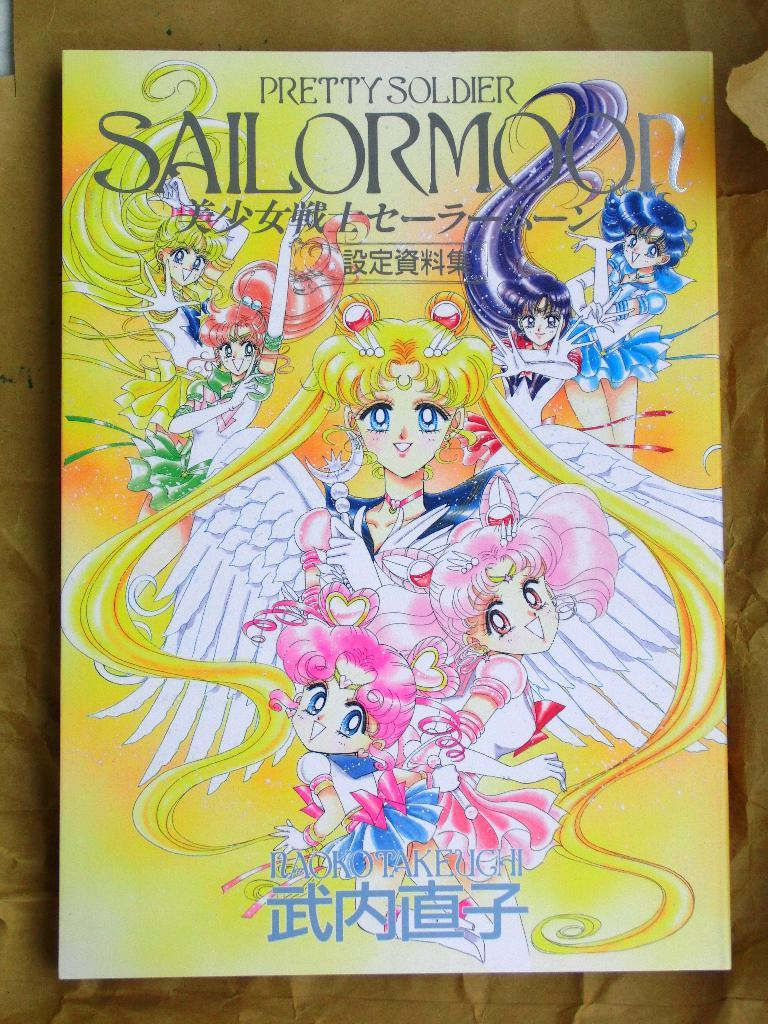<image>
Render a clear and concise summary of the photo. a book that says pretty soldier at the top 